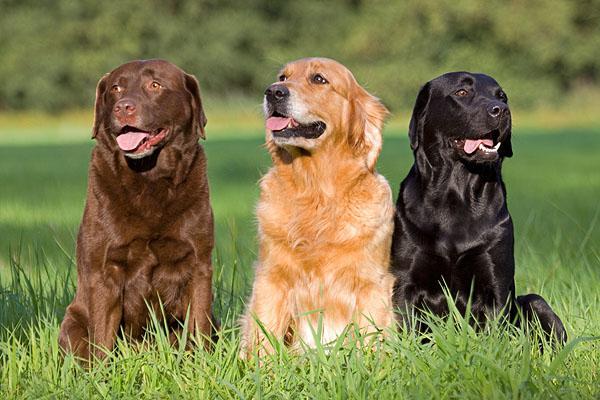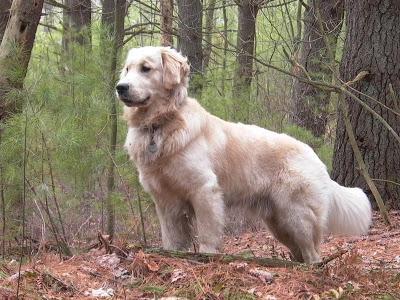The first image is the image on the left, the second image is the image on the right. Examine the images to the left and right. Is the description "An image shows two beige pups and one black pup." accurate? Answer yes or no. No. 